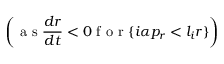Convert formula to latex. <formula><loc_0><loc_0><loc_500><loc_500>\left ( a s \frac { d r } { d t } < 0 f o r \{ i \alpha p _ { r } < l _ { i } r \} \right )</formula> 